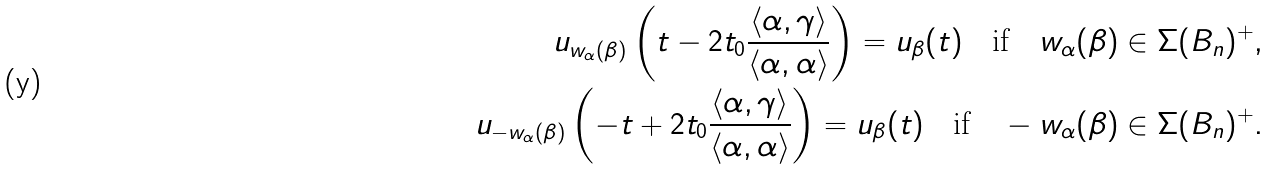<formula> <loc_0><loc_0><loc_500><loc_500>u _ { w _ { \alpha } ( \beta ) } \left ( t - 2 t _ { 0 } \frac { \langle \alpha , \gamma \rangle } { \langle \alpha , \alpha \rangle } \right ) = u _ { \beta } ( t ) \quad \text {if} \quad w _ { \alpha } ( \beta ) \in \Sigma ( B _ { n } ) ^ { + } , \\ u _ { - w _ { \alpha } ( \beta ) } \left ( - t + 2 t _ { 0 } \frac { \langle \alpha , \gamma \rangle } { \langle \alpha , \alpha \rangle } \right ) = u _ { \beta } ( t ) \quad \text {if} \quad - w _ { \alpha } ( \beta ) \in \Sigma ( B _ { n } ) ^ { + } .</formula> 